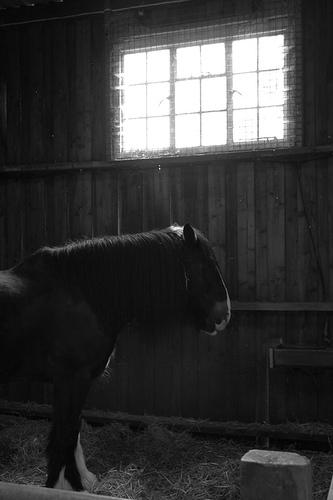Question: how many horses are in the photo?
Choices:
A. 2.
B. 1.
C. 5.
D. 6.
Answer with the letter. Answer: B Question: where is the window?
Choices:
A. Above the horse.
B. Below the horse.
C. To the left of the horse.
D. To the right of the horse.
Answer with the letter. Answer: A Question: what color is the horse?
Choices:
A. Brown.
B. White.
C. Black.
D. Gray.
Answer with the letter. Answer: A 